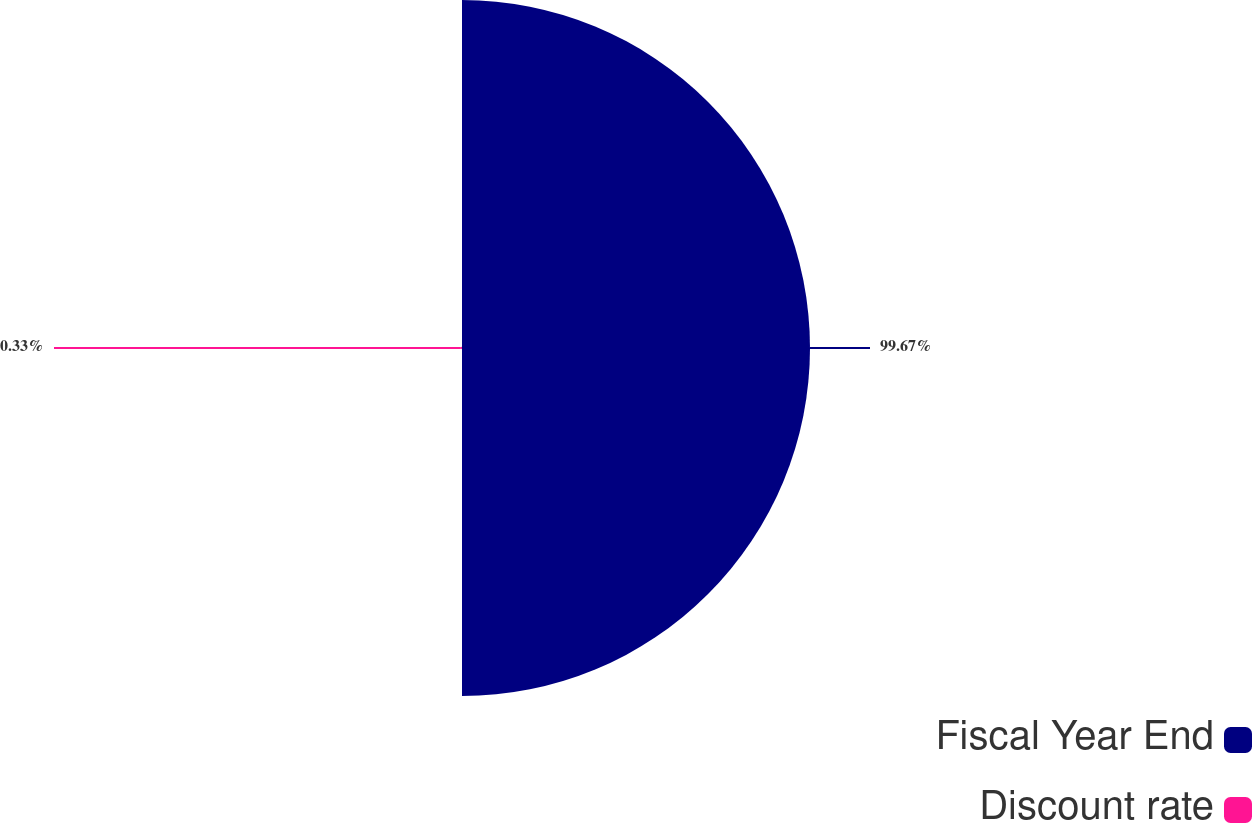Convert chart. <chart><loc_0><loc_0><loc_500><loc_500><pie_chart><fcel>Fiscal Year End<fcel>Discount rate<nl><fcel>99.67%<fcel>0.33%<nl></chart> 